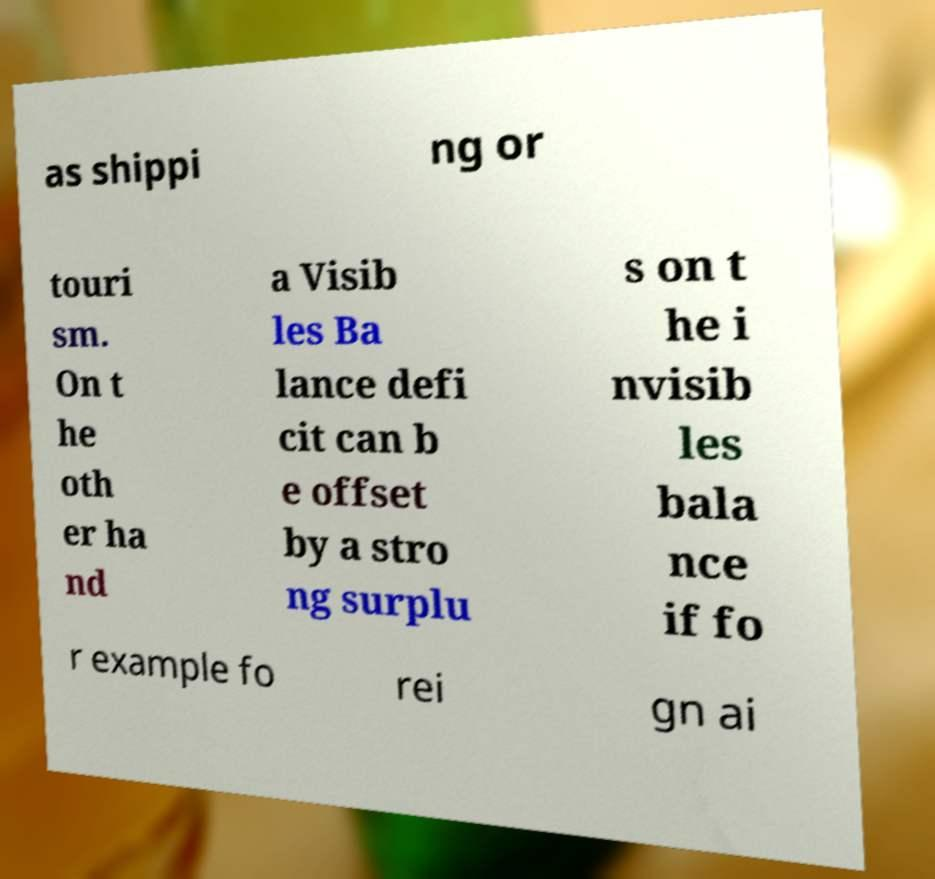Please read and relay the text visible in this image. What does it say? as shippi ng or touri sm. On t he oth er ha nd a Visib les Ba lance defi cit can b e offset by a stro ng surplu s on t he i nvisib les bala nce if fo r example fo rei gn ai 